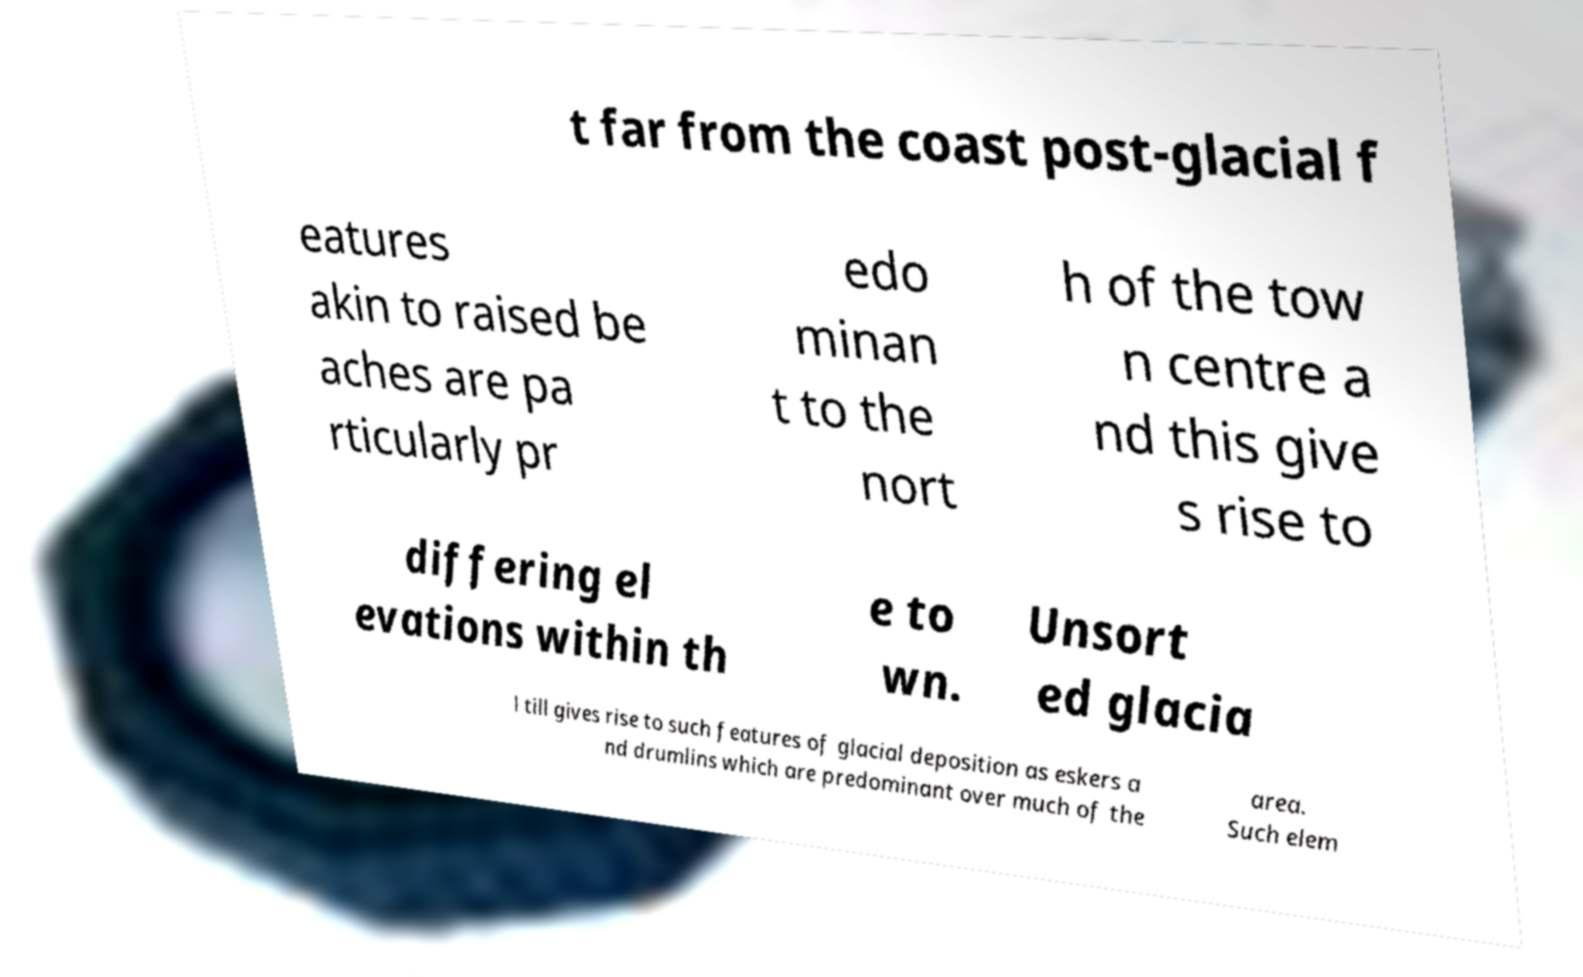Could you extract and type out the text from this image? t far from the coast post-glacial f eatures akin to raised be aches are pa rticularly pr edo minan t to the nort h of the tow n centre a nd this give s rise to differing el evations within th e to wn. Unsort ed glacia l till gives rise to such features of glacial deposition as eskers a nd drumlins which are predominant over much of the area. Such elem 